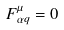<formula> <loc_0><loc_0><loc_500><loc_500>F ^ { \mu } _ { \alpha q } = 0</formula> 